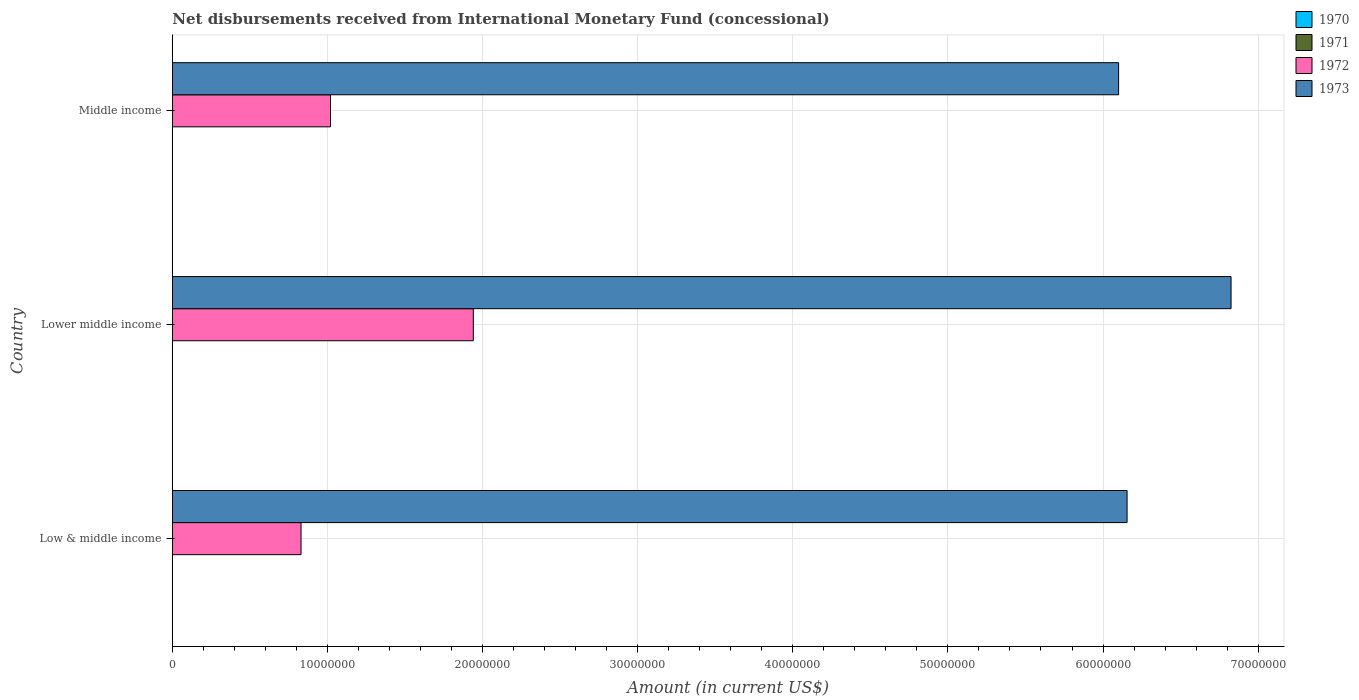Are the number of bars on each tick of the Y-axis equal?
Make the answer very short. Yes. In how many cases, is the number of bars for a given country not equal to the number of legend labels?
Offer a very short reply. 3. What is the amount of disbursements received from International Monetary Fund in 1973 in Lower middle income?
Provide a succinct answer. 6.83e+07. Across all countries, what is the maximum amount of disbursements received from International Monetary Fund in 1972?
Your answer should be compact. 1.94e+07. Across all countries, what is the minimum amount of disbursements received from International Monetary Fund in 1972?
Make the answer very short. 8.30e+06. In which country was the amount of disbursements received from International Monetary Fund in 1972 maximum?
Ensure brevity in your answer.  Lower middle income. What is the difference between the amount of disbursements received from International Monetary Fund in 1973 in Low & middle income and that in Lower middle income?
Keep it short and to the point. -6.70e+06. What is the difference between the amount of disbursements received from International Monetary Fund in 1972 in Lower middle income and the amount of disbursements received from International Monetary Fund in 1973 in Low & middle income?
Your response must be concise. -4.21e+07. What is the average amount of disbursements received from International Monetary Fund in 1971 per country?
Ensure brevity in your answer.  0. What is the ratio of the amount of disbursements received from International Monetary Fund in 1972 in Low & middle income to that in Lower middle income?
Ensure brevity in your answer.  0.43. What is the difference between the highest and the second highest amount of disbursements received from International Monetary Fund in 1973?
Ensure brevity in your answer.  6.70e+06. What is the difference between the highest and the lowest amount of disbursements received from International Monetary Fund in 1972?
Provide a short and direct response. 1.11e+07. In how many countries, is the amount of disbursements received from International Monetary Fund in 1971 greater than the average amount of disbursements received from International Monetary Fund in 1971 taken over all countries?
Ensure brevity in your answer.  0. Is the sum of the amount of disbursements received from International Monetary Fund in 1973 in Lower middle income and Middle income greater than the maximum amount of disbursements received from International Monetary Fund in 1971 across all countries?
Your answer should be compact. Yes. Is it the case that in every country, the sum of the amount of disbursements received from International Monetary Fund in 1970 and amount of disbursements received from International Monetary Fund in 1972 is greater than the sum of amount of disbursements received from International Monetary Fund in 1971 and amount of disbursements received from International Monetary Fund in 1973?
Keep it short and to the point. Yes. Are all the bars in the graph horizontal?
Ensure brevity in your answer.  Yes. How many countries are there in the graph?
Make the answer very short. 3. What is the difference between two consecutive major ticks on the X-axis?
Ensure brevity in your answer.  1.00e+07. Does the graph contain grids?
Make the answer very short. Yes. Where does the legend appear in the graph?
Your answer should be compact. Top right. How many legend labels are there?
Offer a very short reply. 4. How are the legend labels stacked?
Provide a succinct answer. Vertical. What is the title of the graph?
Your answer should be very brief. Net disbursements received from International Monetary Fund (concessional). What is the label or title of the Y-axis?
Provide a succinct answer. Country. What is the Amount (in current US$) in 1972 in Low & middle income?
Offer a terse response. 8.30e+06. What is the Amount (in current US$) in 1973 in Low & middle income?
Your answer should be very brief. 6.16e+07. What is the Amount (in current US$) of 1971 in Lower middle income?
Keep it short and to the point. 0. What is the Amount (in current US$) of 1972 in Lower middle income?
Keep it short and to the point. 1.94e+07. What is the Amount (in current US$) of 1973 in Lower middle income?
Provide a succinct answer. 6.83e+07. What is the Amount (in current US$) of 1970 in Middle income?
Provide a succinct answer. 0. What is the Amount (in current US$) in 1972 in Middle income?
Your answer should be very brief. 1.02e+07. What is the Amount (in current US$) of 1973 in Middle income?
Your answer should be compact. 6.10e+07. Across all countries, what is the maximum Amount (in current US$) in 1972?
Keep it short and to the point. 1.94e+07. Across all countries, what is the maximum Amount (in current US$) in 1973?
Provide a short and direct response. 6.83e+07. Across all countries, what is the minimum Amount (in current US$) of 1972?
Your answer should be very brief. 8.30e+06. Across all countries, what is the minimum Amount (in current US$) of 1973?
Provide a succinct answer. 6.10e+07. What is the total Amount (in current US$) in 1970 in the graph?
Give a very brief answer. 0. What is the total Amount (in current US$) in 1972 in the graph?
Keep it short and to the point. 3.79e+07. What is the total Amount (in current US$) of 1973 in the graph?
Give a very brief answer. 1.91e+08. What is the difference between the Amount (in current US$) of 1972 in Low & middle income and that in Lower middle income?
Your answer should be compact. -1.11e+07. What is the difference between the Amount (in current US$) in 1973 in Low & middle income and that in Lower middle income?
Give a very brief answer. -6.70e+06. What is the difference between the Amount (in current US$) in 1972 in Low & middle income and that in Middle income?
Provide a short and direct response. -1.90e+06. What is the difference between the Amount (in current US$) of 1973 in Low & middle income and that in Middle income?
Offer a terse response. 5.46e+05. What is the difference between the Amount (in current US$) in 1972 in Lower middle income and that in Middle income?
Make the answer very short. 9.21e+06. What is the difference between the Amount (in current US$) in 1973 in Lower middle income and that in Middle income?
Your response must be concise. 7.25e+06. What is the difference between the Amount (in current US$) in 1972 in Low & middle income and the Amount (in current US$) in 1973 in Lower middle income?
Provide a succinct answer. -6.00e+07. What is the difference between the Amount (in current US$) of 1972 in Low & middle income and the Amount (in current US$) of 1973 in Middle income?
Keep it short and to the point. -5.27e+07. What is the difference between the Amount (in current US$) of 1972 in Lower middle income and the Amount (in current US$) of 1973 in Middle income?
Keep it short and to the point. -4.16e+07. What is the average Amount (in current US$) in 1971 per country?
Offer a terse response. 0. What is the average Amount (in current US$) in 1972 per country?
Your answer should be very brief. 1.26e+07. What is the average Amount (in current US$) of 1973 per country?
Provide a short and direct response. 6.36e+07. What is the difference between the Amount (in current US$) in 1972 and Amount (in current US$) in 1973 in Low & middle income?
Keep it short and to the point. -5.33e+07. What is the difference between the Amount (in current US$) of 1972 and Amount (in current US$) of 1973 in Lower middle income?
Your response must be concise. -4.89e+07. What is the difference between the Amount (in current US$) in 1972 and Amount (in current US$) in 1973 in Middle income?
Ensure brevity in your answer.  -5.08e+07. What is the ratio of the Amount (in current US$) in 1972 in Low & middle income to that in Lower middle income?
Your answer should be very brief. 0.43. What is the ratio of the Amount (in current US$) in 1973 in Low & middle income to that in Lower middle income?
Provide a succinct answer. 0.9. What is the ratio of the Amount (in current US$) of 1972 in Low & middle income to that in Middle income?
Make the answer very short. 0.81. What is the ratio of the Amount (in current US$) in 1972 in Lower middle income to that in Middle income?
Make the answer very short. 1.9. What is the ratio of the Amount (in current US$) of 1973 in Lower middle income to that in Middle income?
Your response must be concise. 1.12. What is the difference between the highest and the second highest Amount (in current US$) of 1972?
Make the answer very short. 9.21e+06. What is the difference between the highest and the second highest Amount (in current US$) in 1973?
Provide a short and direct response. 6.70e+06. What is the difference between the highest and the lowest Amount (in current US$) of 1972?
Offer a very short reply. 1.11e+07. What is the difference between the highest and the lowest Amount (in current US$) of 1973?
Keep it short and to the point. 7.25e+06. 